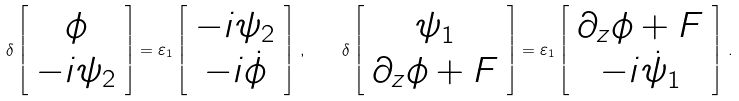<formula> <loc_0><loc_0><loc_500><loc_500>\delta \left [ \begin{array} { c } \phi \\ - i \psi _ { 2 } \end{array} \right ] = \varepsilon _ { 1 } \left [ \begin{array} { c } - i \psi _ { 2 } \\ - i \dot { \phi } \end{array} \right ] \, , \quad \delta \left [ \begin{array} { c } \psi _ { 1 } \\ \partial _ { z } \phi + F \end{array} \right ] = \varepsilon _ { 1 } \left [ \begin{array} { c } \partial _ { z } \phi + F \\ - i \dot { \psi } _ { 1 } \end{array} \right ] \, .</formula> 